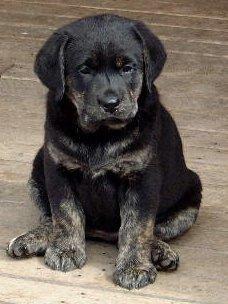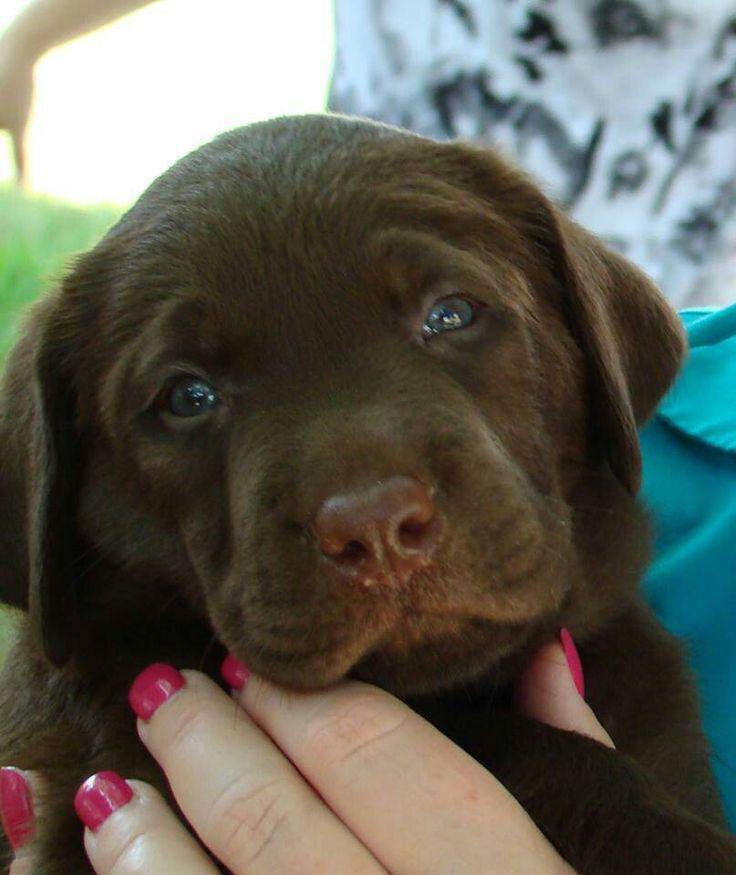The first image is the image on the left, the second image is the image on the right. Considering the images on both sides, is "A brown puppy is posed on a printed fabric surface." valid? Answer yes or no. No. The first image is the image on the left, the second image is the image on the right. For the images shown, is this caption "the animal in the image on the left is in a container" true? Answer yes or no. No. 